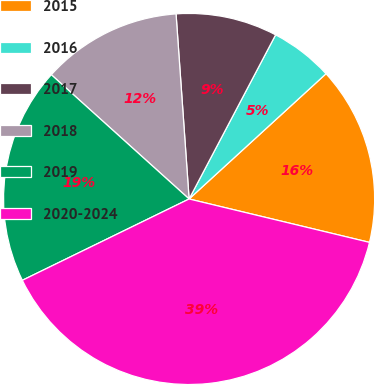Convert chart to OTSL. <chart><loc_0><loc_0><loc_500><loc_500><pie_chart><fcel>2015<fcel>2016<fcel>2017<fcel>2018<fcel>2019<fcel>2020-2024<nl><fcel>15.55%<fcel>5.49%<fcel>8.84%<fcel>12.2%<fcel>18.9%<fcel>39.02%<nl></chart> 